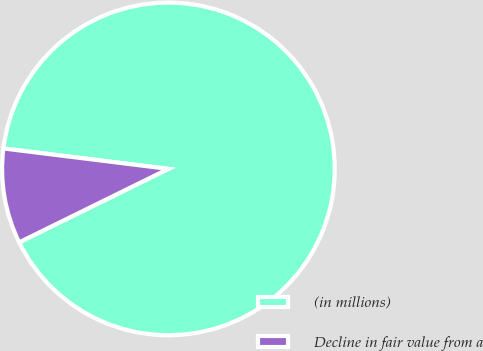Convert chart to OTSL. <chart><loc_0><loc_0><loc_500><loc_500><pie_chart><fcel>(in millions)<fcel>Decline in fair value from a<nl><fcel>90.76%<fcel>9.24%<nl></chart> 